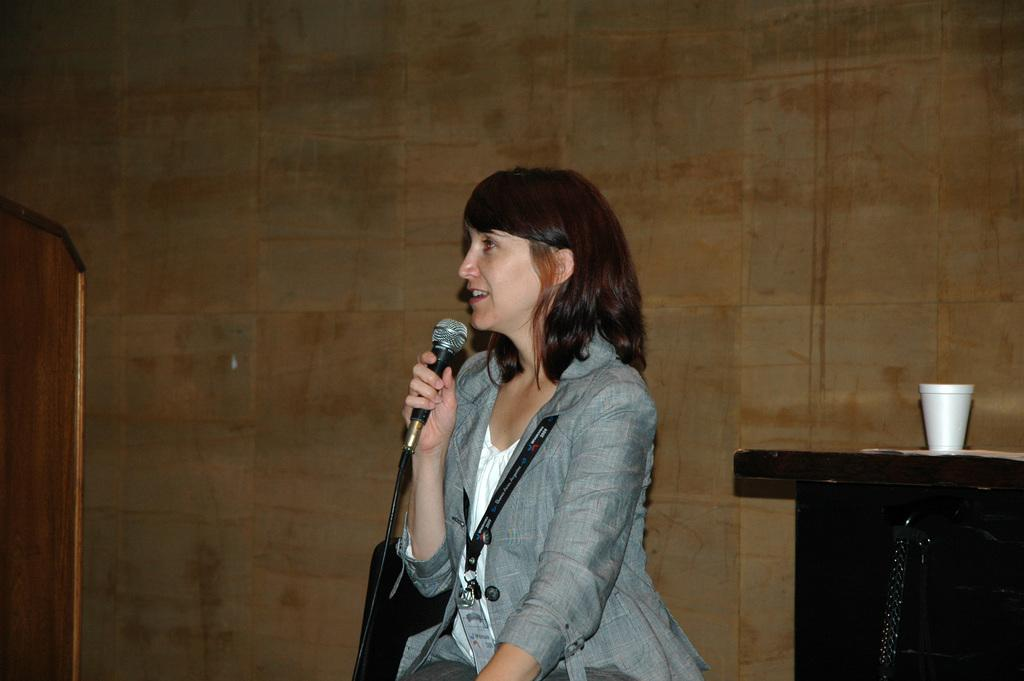Who is the main subject in the image? There is a lady in the image. What is the lady wearing? The lady is wearing a grey jacket. What is the lady doing in the image? The lady is sitting and holding a mic in her hand. What can be seen to the right side of the image? There is a table to the right side of the image. What items are on the table? There are two cups on the table. What type of string is the lady using to hold the mic in the image? There is no string visible in the image; the lady is holding the mic with her hand. 